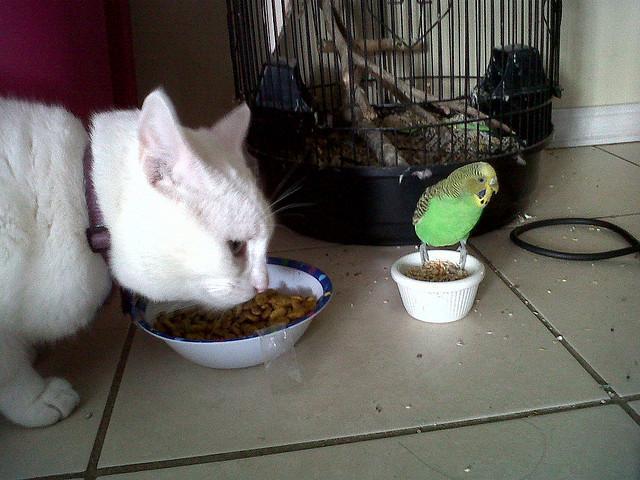How many pets are present?
Give a very brief answer. 2. How many bowls can you see?
Give a very brief answer. 2. 